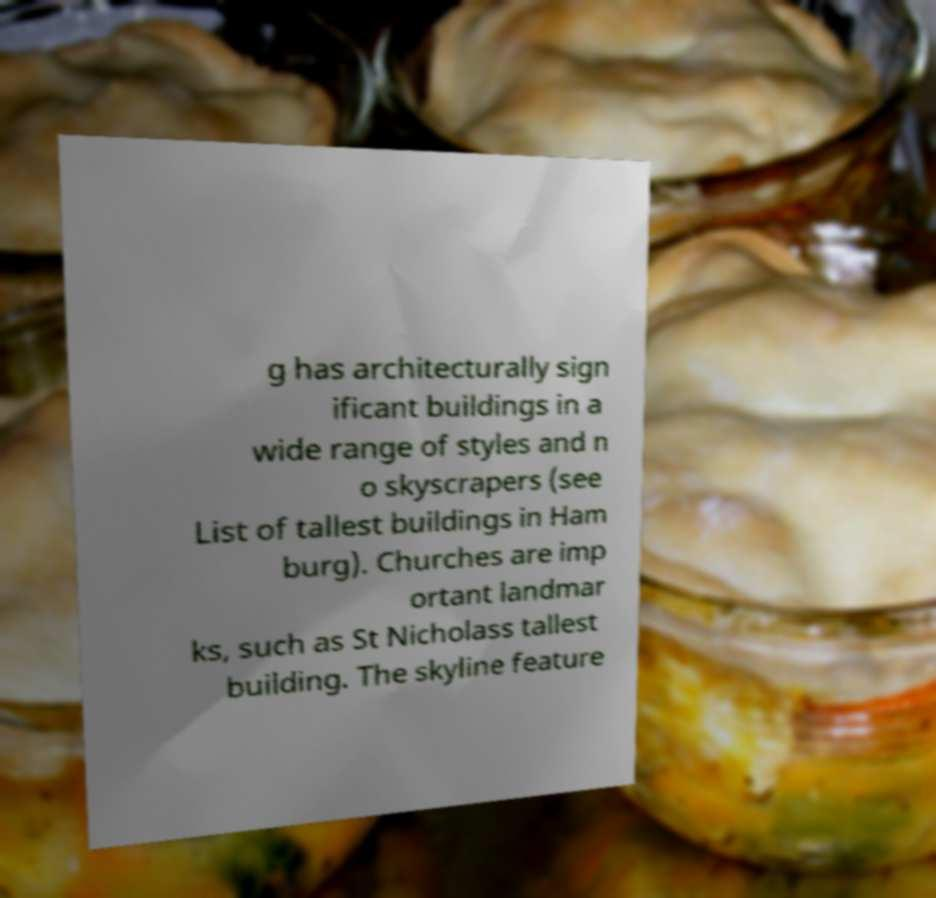What messages or text are displayed in this image? I need them in a readable, typed format. g has architecturally sign ificant buildings in a wide range of styles and n o skyscrapers (see List of tallest buildings in Ham burg). Churches are imp ortant landmar ks, such as St Nicholass tallest building. The skyline feature 